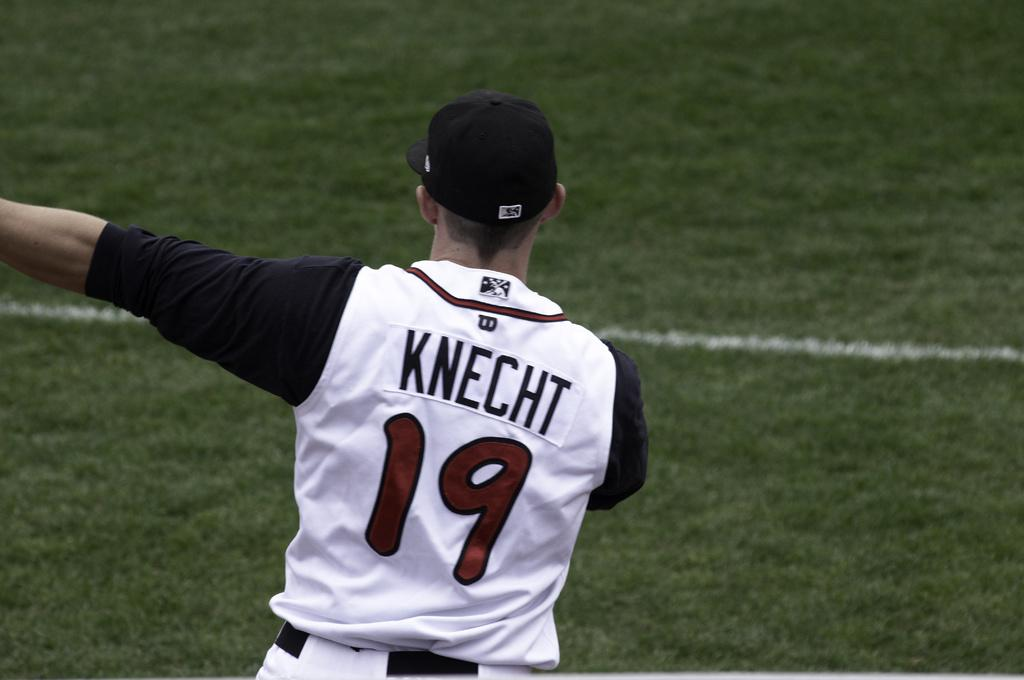Who is the main subject in the image? There is a man in the center of the image. What is the man doing in the image? The man is standing. What type of clothing is the man wearing? The man is wearing a sport dress and a hat. What can be seen on the man's T-shirt? There is text on the man's T-shirt. What is visible in the background of the image? The ground is visible in the background of the image. What type of collar can be seen on the man's shirt in the image? There is no collar visible on the man's shirt in the image, as he is wearing a sport dress. What disease is the man suffering from in the image? There is no indication of any disease in the image; the man is simply standing and wearing a sport dress. 